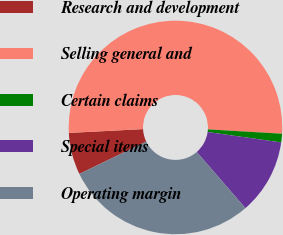<chart> <loc_0><loc_0><loc_500><loc_500><pie_chart><fcel>Research and development<fcel>Selling general and<fcel>Certain claims<fcel>Special items<fcel>Operating margin<nl><fcel>6.35%<fcel>51.75%<fcel>1.3%<fcel>11.39%<fcel>29.2%<nl></chart> 